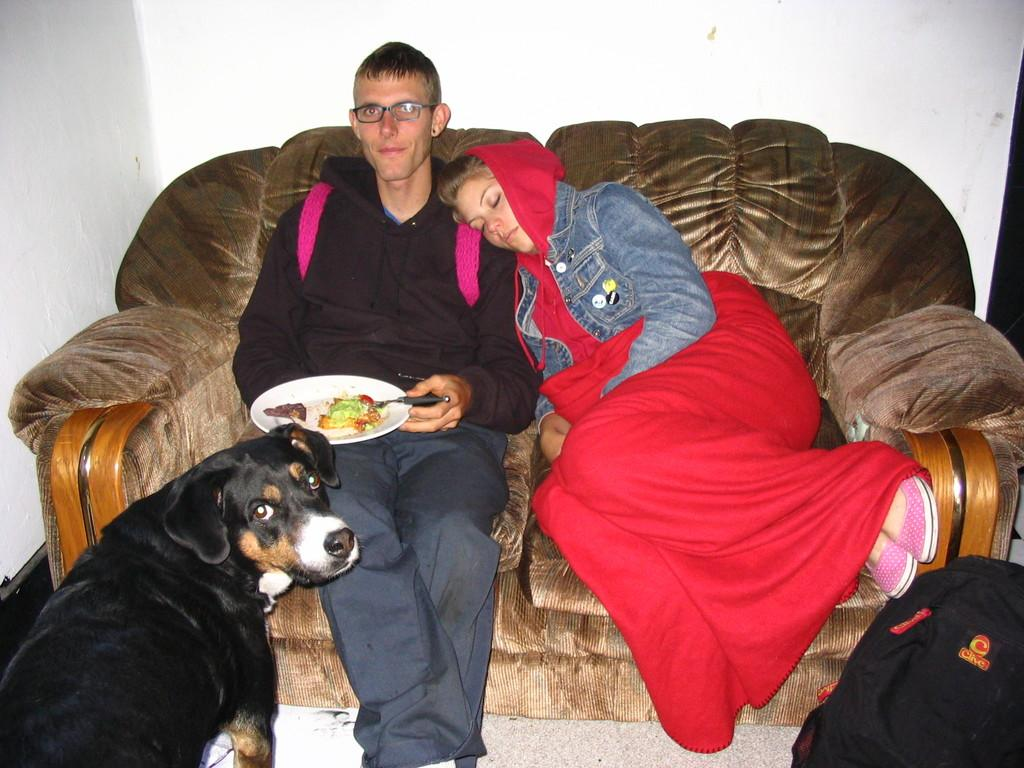Who is present in the image? There is a man and a woman in the image. What are they doing in the image? Both the man and woman are sitting on a sofa. What is the man holding in the image? The man is holding a plate. What is in front of the man in the image? There is a dog and a bag in front of the man. What is on the plate that the man is holding? There is food on the plate. What type of apparatus is being used by the rabbits in the image? There are no rabbits present in the image, so there is no apparatus being used by them. 